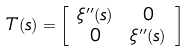<formula> <loc_0><loc_0><loc_500><loc_500>T ( s ) & = \left [ \begin{array} { c c } \xi ^ { \prime \prime } ( s ) & 0 \\ 0 & \xi ^ { \prime \prime } ( s ) \end{array} \right ]</formula> 